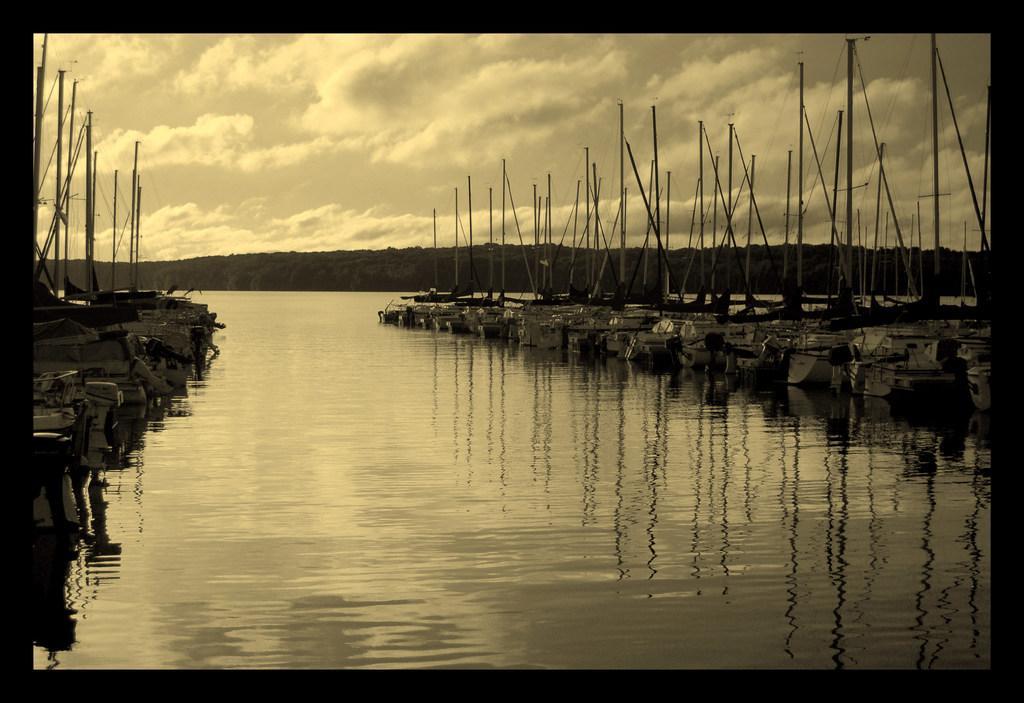Describe this image in one or two sentences. At the bottom of the image we can see water, above the water we can see some boats. In the middle of the image we can see some trees. At the top of the image we can see some clouds in the sky. 